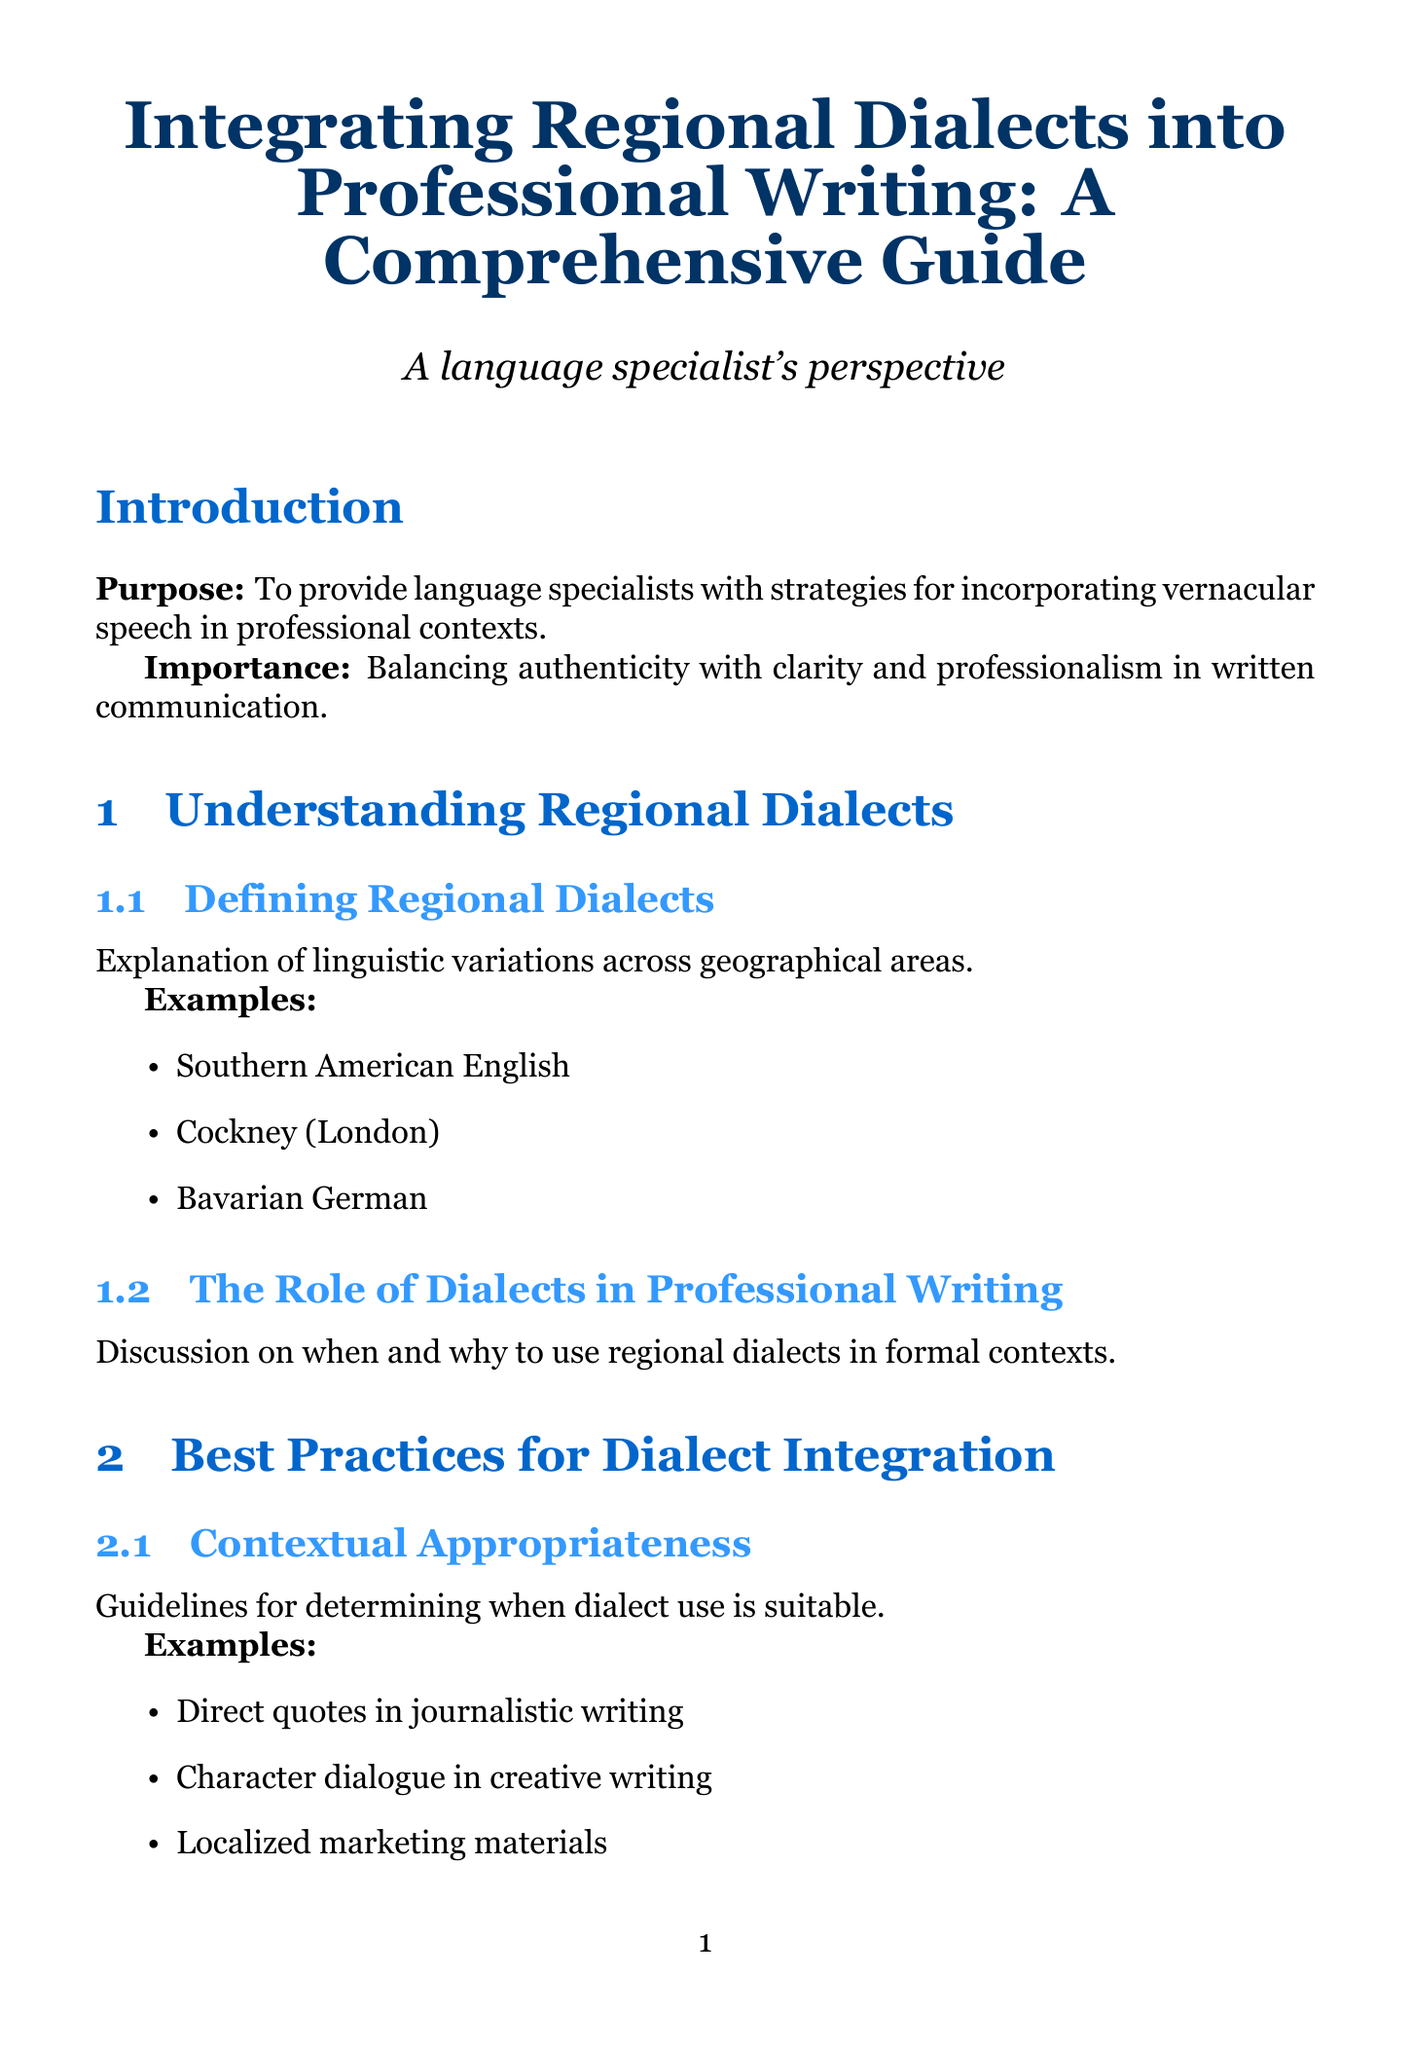What is the title of the document? The title is stated at the beginning of the document, summarizing the main topic it addresses.
Answer: Integrating Regional Dialects into Professional Writing: A Comprehensive Guide How many chapters are in the document? The document lists several main sections, indicating the number of chapters included.
Answer: Six What is one example of a regional dialect mentioned? The document provides specific examples of regional dialects within the section on defining them.
Answer: Southern American English What is the purpose of the guide? The purpose is summarized in the introduction, providing insight into the main goal of the document.
Answer: To provide language specialists with strategies for incorporating vernacular speech in professional contexts What is a technique for maintaining clarity when using dialect? The document includes strategies for ensuring comprehension while integrating dialects in writing.
Answer: Providing translations or explanations in footnotes What ethical consideration is highlighted in the guide? The document features a section dedicated to ethical aspects of dialect integration, outlining significant guidelines.
Answer: Avoiding Stereotypes and Caricatures What type of writing is appropriate for using dialect, according to best practices? The content discusses contextual appropriateness in dialect use for various writing forms, giving examples.
Answer: Direct quotes in journalistic writing What resource is recommended for dialect-specific vocabulary? The document lists helpful tools that language specialists can utilize, including dictionaries.
Answer: Dictionary of American Regional English (DARE) Which case study focuses on a literary work? The document provides an analysis of various case studies, one of which examines a specific novel.
Answer: Irvine Welsh's 'Trainspotting' 